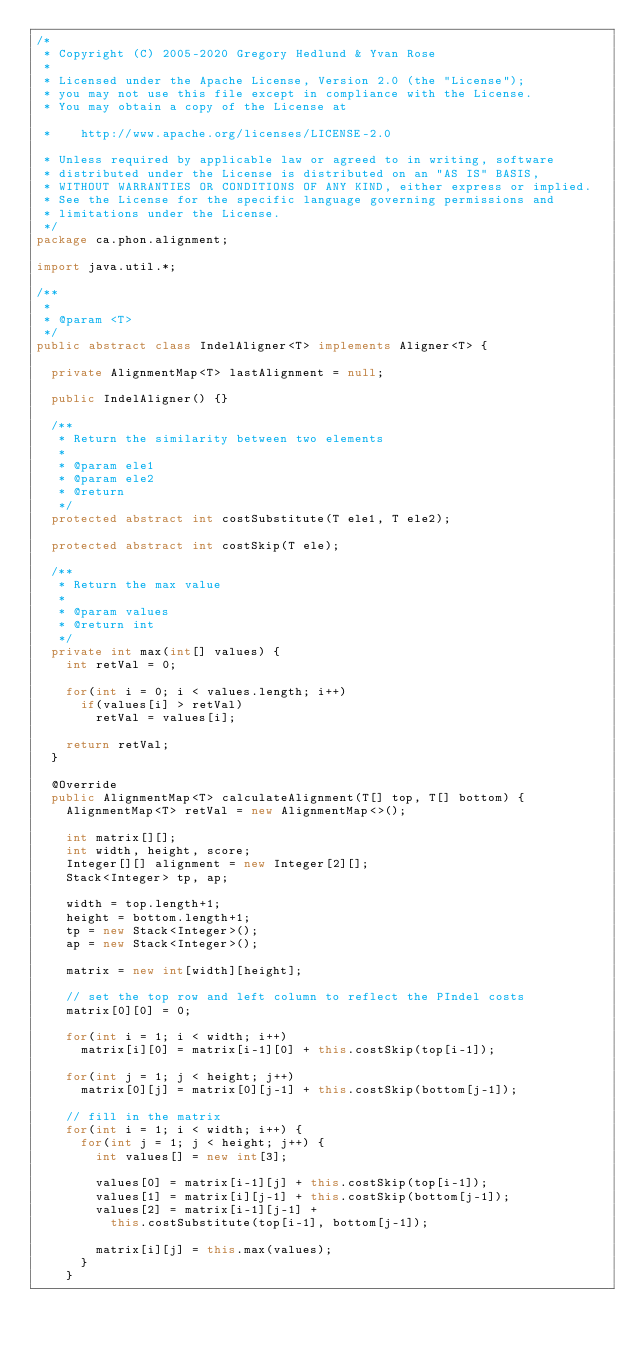<code> <loc_0><loc_0><loc_500><loc_500><_Java_>/*
 * Copyright (C) 2005-2020 Gregory Hedlund & Yvan Rose
 * 
 * Licensed under the Apache License, Version 2.0 (the "License");
 * you may not use this file except in compliance with the License.
 * You may obtain a copy of the License at

 *    http://www.apache.org/licenses/LICENSE-2.0

 * Unless required by applicable law or agreed to in writing, software
 * distributed under the License is distributed on an "AS IS" BASIS,
 * WITHOUT WARRANTIES OR CONDITIONS OF ANY KIND, either express or implied.
 * See the License for the specific language governing permissions and
 * limitations under the License.
 */
package ca.phon.alignment;

import java.util.*;

/**
 * 
 * @param <T>
 */
public abstract class IndelAligner<T> implements Aligner<T> {
	
	private AlignmentMap<T> lastAlignment = null;

	public IndelAligner() {}
	
	/**
	 * Return the similarity between two elements
	 * 
	 * @param ele1
	 * @param ele2
	 * @return
	 */
	protected abstract int costSubstitute(T ele1, T ele2);
	
	protected abstract int costSkip(T ele);

	/**
	 * Return the max value
	 * 
	 * @param values
	 * @return int
	 */
	private int max(int[] values) {
		int retVal = 0;
		
		for(int i = 0; i < values.length; i++)
			if(values[i] > retVal)
				retVal = values[i];
		
		return retVal;
	}
	
	@Override
	public AlignmentMap<T> calculateAlignment(T[] top, T[] bottom) {
		AlignmentMap<T> retVal = new AlignmentMap<>();
		
		int matrix[][];
		int width, height, score;
		Integer[][] alignment = new Integer[2][];
		Stack<Integer> tp, ap;
		
		width = top.length+1;
		height = bottom.length+1;
		tp = new Stack<Integer>();
		ap = new Stack<Integer>();
		
		matrix = new int[width][height];
		
		// set the top row and left column to reflect the PIndel costs
		matrix[0][0] = 0;
		
		for(int i = 1; i < width; i++)
			matrix[i][0] = matrix[i-1][0] + this.costSkip(top[i-1]);
		
		for(int j = 1; j < height; j++)
			matrix[0][j] = matrix[0][j-1] + this.costSkip(bottom[j-1]);
		
		// fill in the matrix
		for(int i = 1; i < width; i++) {
			for(int j = 1; j < height; j++) {
				int values[] = new int[3];
				
				values[0] = matrix[i-1][j] + this.costSkip(top[i-1]);
				values[1] = matrix[i][j-1] + this.costSkip(bottom[j-1]);
				values[2] = matrix[i-1][j-1] + 
					this.costSubstitute(top[i-1], bottom[j-1]);
				
				matrix[i][j] = this.max(values);
			}
		}
		</code> 